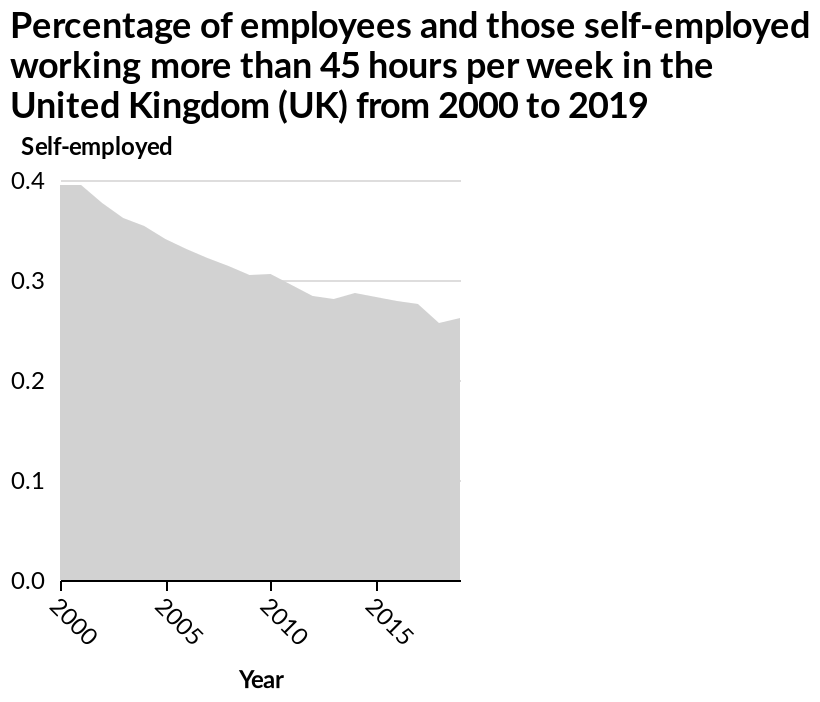<image>
Are self employed people working fewer hours over time? Yes, the chart indicates that self employed people in 2015 work fewer hours on average compared to those in 2000. What is the name of the area diagram described in the given information? The area diagram is called "Percentage of employees and those self-employed working more than 45 hours per week in the United Kingdom (UK) from 2000 to 2019." What is plotted on the x-axis of the area diagram? The x-axis of the area diagram represents the "Year" from 2000 to 2019. Is there a difference in the average working hours of self employed people between 2000 and 2015? Yes, there is a difference in the average working hours of self employed people between 2000 and 2015. Self employed people in 2000 worked longer hours than those in 2015. 